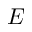Convert formula to latex. <formula><loc_0><loc_0><loc_500><loc_500>E</formula> 